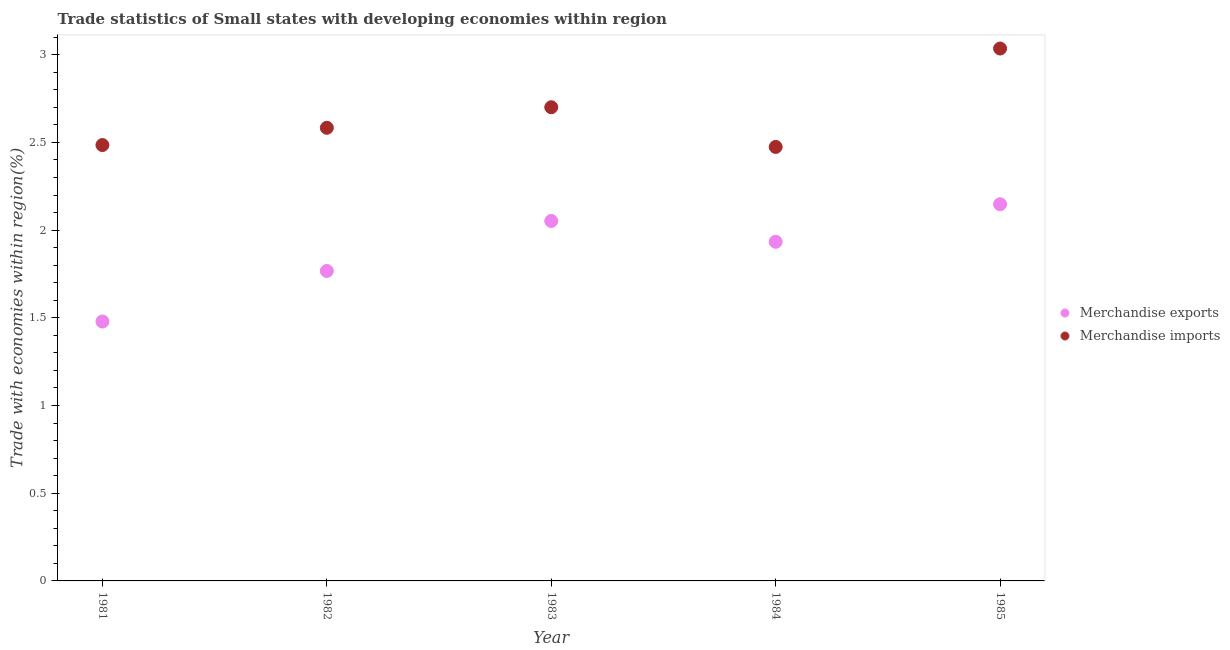What is the merchandise imports in 1984?
Your response must be concise. 2.47. Across all years, what is the maximum merchandise imports?
Provide a short and direct response. 3.04. Across all years, what is the minimum merchandise exports?
Ensure brevity in your answer.  1.48. In which year was the merchandise exports minimum?
Ensure brevity in your answer.  1981. What is the total merchandise imports in the graph?
Your answer should be very brief. 13.28. What is the difference between the merchandise exports in 1983 and that in 1985?
Your answer should be very brief. -0.1. What is the difference between the merchandise imports in 1982 and the merchandise exports in 1984?
Your response must be concise. 0.65. What is the average merchandise exports per year?
Your answer should be very brief. 1.88. In the year 1982, what is the difference between the merchandise exports and merchandise imports?
Your answer should be very brief. -0.82. In how many years, is the merchandise exports greater than 2.3 %?
Make the answer very short. 0. What is the ratio of the merchandise imports in 1982 to that in 1985?
Provide a succinct answer. 0.85. Is the merchandise imports in 1982 less than that in 1984?
Offer a terse response. No. What is the difference between the highest and the second highest merchandise imports?
Provide a succinct answer. 0.33. What is the difference between the highest and the lowest merchandise imports?
Your answer should be very brief. 0.56. In how many years, is the merchandise exports greater than the average merchandise exports taken over all years?
Give a very brief answer. 3. Is the sum of the merchandise exports in 1982 and 1984 greater than the maximum merchandise imports across all years?
Keep it short and to the point. Yes. Does the merchandise imports monotonically increase over the years?
Keep it short and to the point. No. How many dotlines are there?
Make the answer very short. 2. How many years are there in the graph?
Make the answer very short. 5. Are the values on the major ticks of Y-axis written in scientific E-notation?
Give a very brief answer. No. Does the graph contain any zero values?
Your answer should be very brief. No. Does the graph contain grids?
Your answer should be compact. No. Where does the legend appear in the graph?
Ensure brevity in your answer.  Center right. How many legend labels are there?
Your answer should be very brief. 2. How are the legend labels stacked?
Your answer should be very brief. Vertical. What is the title of the graph?
Make the answer very short. Trade statistics of Small states with developing economies within region. Does "Resident" appear as one of the legend labels in the graph?
Offer a terse response. No. What is the label or title of the X-axis?
Your answer should be very brief. Year. What is the label or title of the Y-axis?
Offer a terse response. Trade with economies within region(%). What is the Trade with economies within region(%) of Merchandise exports in 1981?
Provide a short and direct response. 1.48. What is the Trade with economies within region(%) in Merchandise imports in 1981?
Your answer should be compact. 2.48. What is the Trade with economies within region(%) in Merchandise exports in 1982?
Your response must be concise. 1.77. What is the Trade with economies within region(%) in Merchandise imports in 1982?
Offer a terse response. 2.58. What is the Trade with economies within region(%) in Merchandise exports in 1983?
Provide a short and direct response. 2.05. What is the Trade with economies within region(%) of Merchandise imports in 1983?
Your answer should be compact. 2.7. What is the Trade with economies within region(%) in Merchandise exports in 1984?
Give a very brief answer. 1.93. What is the Trade with economies within region(%) in Merchandise imports in 1984?
Make the answer very short. 2.47. What is the Trade with economies within region(%) in Merchandise exports in 1985?
Offer a terse response. 2.15. What is the Trade with economies within region(%) in Merchandise imports in 1985?
Provide a succinct answer. 3.04. Across all years, what is the maximum Trade with economies within region(%) of Merchandise exports?
Provide a succinct answer. 2.15. Across all years, what is the maximum Trade with economies within region(%) in Merchandise imports?
Your answer should be very brief. 3.04. Across all years, what is the minimum Trade with economies within region(%) of Merchandise exports?
Provide a succinct answer. 1.48. Across all years, what is the minimum Trade with economies within region(%) of Merchandise imports?
Keep it short and to the point. 2.47. What is the total Trade with economies within region(%) of Merchandise exports in the graph?
Offer a very short reply. 9.38. What is the total Trade with economies within region(%) of Merchandise imports in the graph?
Make the answer very short. 13.28. What is the difference between the Trade with economies within region(%) of Merchandise exports in 1981 and that in 1982?
Make the answer very short. -0.29. What is the difference between the Trade with economies within region(%) of Merchandise imports in 1981 and that in 1982?
Your answer should be very brief. -0.1. What is the difference between the Trade with economies within region(%) in Merchandise exports in 1981 and that in 1983?
Provide a short and direct response. -0.57. What is the difference between the Trade with economies within region(%) of Merchandise imports in 1981 and that in 1983?
Provide a succinct answer. -0.22. What is the difference between the Trade with economies within region(%) in Merchandise exports in 1981 and that in 1984?
Give a very brief answer. -0.45. What is the difference between the Trade with economies within region(%) of Merchandise imports in 1981 and that in 1984?
Provide a succinct answer. 0.01. What is the difference between the Trade with economies within region(%) in Merchandise exports in 1981 and that in 1985?
Ensure brevity in your answer.  -0.67. What is the difference between the Trade with economies within region(%) in Merchandise imports in 1981 and that in 1985?
Keep it short and to the point. -0.55. What is the difference between the Trade with economies within region(%) of Merchandise exports in 1982 and that in 1983?
Provide a succinct answer. -0.28. What is the difference between the Trade with economies within region(%) in Merchandise imports in 1982 and that in 1983?
Offer a terse response. -0.12. What is the difference between the Trade with economies within region(%) in Merchandise exports in 1982 and that in 1984?
Make the answer very short. -0.17. What is the difference between the Trade with economies within region(%) of Merchandise imports in 1982 and that in 1984?
Your answer should be very brief. 0.11. What is the difference between the Trade with economies within region(%) of Merchandise exports in 1982 and that in 1985?
Your answer should be compact. -0.38. What is the difference between the Trade with economies within region(%) in Merchandise imports in 1982 and that in 1985?
Give a very brief answer. -0.45. What is the difference between the Trade with economies within region(%) of Merchandise exports in 1983 and that in 1984?
Ensure brevity in your answer.  0.12. What is the difference between the Trade with economies within region(%) in Merchandise imports in 1983 and that in 1984?
Your response must be concise. 0.23. What is the difference between the Trade with economies within region(%) of Merchandise exports in 1983 and that in 1985?
Your response must be concise. -0.1. What is the difference between the Trade with economies within region(%) of Merchandise imports in 1983 and that in 1985?
Your response must be concise. -0.33. What is the difference between the Trade with economies within region(%) in Merchandise exports in 1984 and that in 1985?
Make the answer very short. -0.21. What is the difference between the Trade with economies within region(%) of Merchandise imports in 1984 and that in 1985?
Offer a terse response. -0.56. What is the difference between the Trade with economies within region(%) of Merchandise exports in 1981 and the Trade with economies within region(%) of Merchandise imports in 1982?
Your answer should be compact. -1.1. What is the difference between the Trade with economies within region(%) in Merchandise exports in 1981 and the Trade with economies within region(%) in Merchandise imports in 1983?
Ensure brevity in your answer.  -1.22. What is the difference between the Trade with economies within region(%) of Merchandise exports in 1981 and the Trade with economies within region(%) of Merchandise imports in 1984?
Keep it short and to the point. -1. What is the difference between the Trade with economies within region(%) in Merchandise exports in 1981 and the Trade with economies within region(%) in Merchandise imports in 1985?
Provide a succinct answer. -1.56. What is the difference between the Trade with economies within region(%) in Merchandise exports in 1982 and the Trade with economies within region(%) in Merchandise imports in 1983?
Give a very brief answer. -0.93. What is the difference between the Trade with economies within region(%) of Merchandise exports in 1982 and the Trade with economies within region(%) of Merchandise imports in 1984?
Offer a terse response. -0.71. What is the difference between the Trade with economies within region(%) in Merchandise exports in 1982 and the Trade with economies within region(%) in Merchandise imports in 1985?
Offer a very short reply. -1.27. What is the difference between the Trade with economies within region(%) of Merchandise exports in 1983 and the Trade with economies within region(%) of Merchandise imports in 1984?
Provide a short and direct response. -0.42. What is the difference between the Trade with economies within region(%) of Merchandise exports in 1983 and the Trade with economies within region(%) of Merchandise imports in 1985?
Give a very brief answer. -0.98. What is the difference between the Trade with economies within region(%) of Merchandise exports in 1984 and the Trade with economies within region(%) of Merchandise imports in 1985?
Ensure brevity in your answer.  -1.1. What is the average Trade with economies within region(%) of Merchandise exports per year?
Your answer should be very brief. 1.88. What is the average Trade with economies within region(%) in Merchandise imports per year?
Offer a terse response. 2.66. In the year 1981, what is the difference between the Trade with economies within region(%) in Merchandise exports and Trade with economies within region(%) in Merchandise imports?
Make the answer very short. -1.01. In the year 1982, what is the difference between the Trade with economies within region(%) in Merchandise exports and Trade with economies within region(%) in Merchandise imports?
Offer a terse response. -0.82. In the year 1983, what is the difference between the Trade with economies within region(%) in Merchandise exports and Trade with economies within region(%) in Merchandise imports?
Keep it short and to the point. -0.65. In the year 1984, what is the difference between the Trade with economies within region(%) of Merchandise exports and Trade with economies within region(%) of Merchandise imports?
Ensure brevity in your answer.  -0.54. In the year 1985, what is the difference between the Trade with economies within region(%) of Merchandise exports and Trade with economies within region(%) of Merchandise imports?
Your response must be concise. -0.89. What is the ratio of the Trade with economies within region(%) of Merchandise exports in 1981 to that in 1982?
Make the answer very short. 0.84. What is the ratio of the Trade with economies within region(%) of Merchandise imports in 1981 to that in 1982?
Provide a short and direct response. 0.96. What is the ratio of the Trade with economies within region(%) of Merchandise exports in 1981 to that in 1983?
Your answer should be very brief. 0.72. What is the ratio of the Trade with economies within region(%) in Merchandise imports in 1981 to that in 1983?
Make the answer very short. 0.92. What is the ratio of the Trade with economies within region(%) of Merchandise exports in 1981 to that in 1984?
Make the answer very short. 0.76. What is the ratio of the Trade with economies within region(%) of Merchandise exports in 1981 to that in 1985?
Provide a short and direct response. 0.69. What is the ratio of the Trade with economies within region(%) in Merchandise imports in 1981 to that in 1985?
Your response must be concise. 0.82. What is the ratio of the Trade with economies within region(%) of Merchandise exports in 1982 to that in 1983?
Your response must be concise. 0.86. What is the ratio of the Trade with economies within region(%) of Merchandise imports in 1982 to that in 1983?
Provide a short and direct response. 0.96. What is the ratio of the Trade with economies within region(%) of Merchandise exports in 1982 to that in 1984?
Provide a succinct answer. 0.91. What is the ratio of the Trade with economies within region(%) of Merchandise imports in 1982 to that in 1984?
Provide a succinct answer. 1.04. What is the ratio of the Trade with economies within region(%) of Merchandise exports in 1982 to that in 1985?
Your answer should be compact. 0.82. What is the ratio of the Trade with economies within region(%) of Merchandise imports in 1982 to that in 1985?
Make the answer very short. 0.85. What is the ratio of the Trade with economies within region(%) of Merchandise exports in 1983 to that in 1984?
Provide a short and direct response. 1.06. What is the ratio of the Trade with economies within region(%) of Merchandise imports in 1983 to that in 1984?
Offer a terse response. 1.09. What is the ratio of the Trade with economies within region(%) in Merchandise exports in 1983 to that in 1985?
Offer a terse response. 0.96. What is the ratio of the Trade with economies within region(%) in Merchandise imports in 1983 to that in 1985?
Give a very brief answer. 0.89. What is the ratio of the Trade with economies within region(%) of Merchandise exports in 1984 to that in 1985?
Offer a terse response. 0.9. What is the ratio of the Trade with economies within region(%) of Merchandise imports in 1984 to that in 1985?
Make the answer very short. 0.82. What is the difference between the highest and the second highest Trade with economies within region(%) of Merchandise exports?
Your answer should be very brief. 0.1. What is the difference between the highest and the second highest Trade with economies within region(%) in Merchandise imports?
Your response must be concise. 0.33. What is the difference between the highest and the lowest Trade with economies within region(%) of Merchandise exports?
Keep it short and to the point. 0.67. What is the difference between the highest and the lowest Trade with economies within region(%) in Merchandise imports?
Make the answer very short. 0.56. 